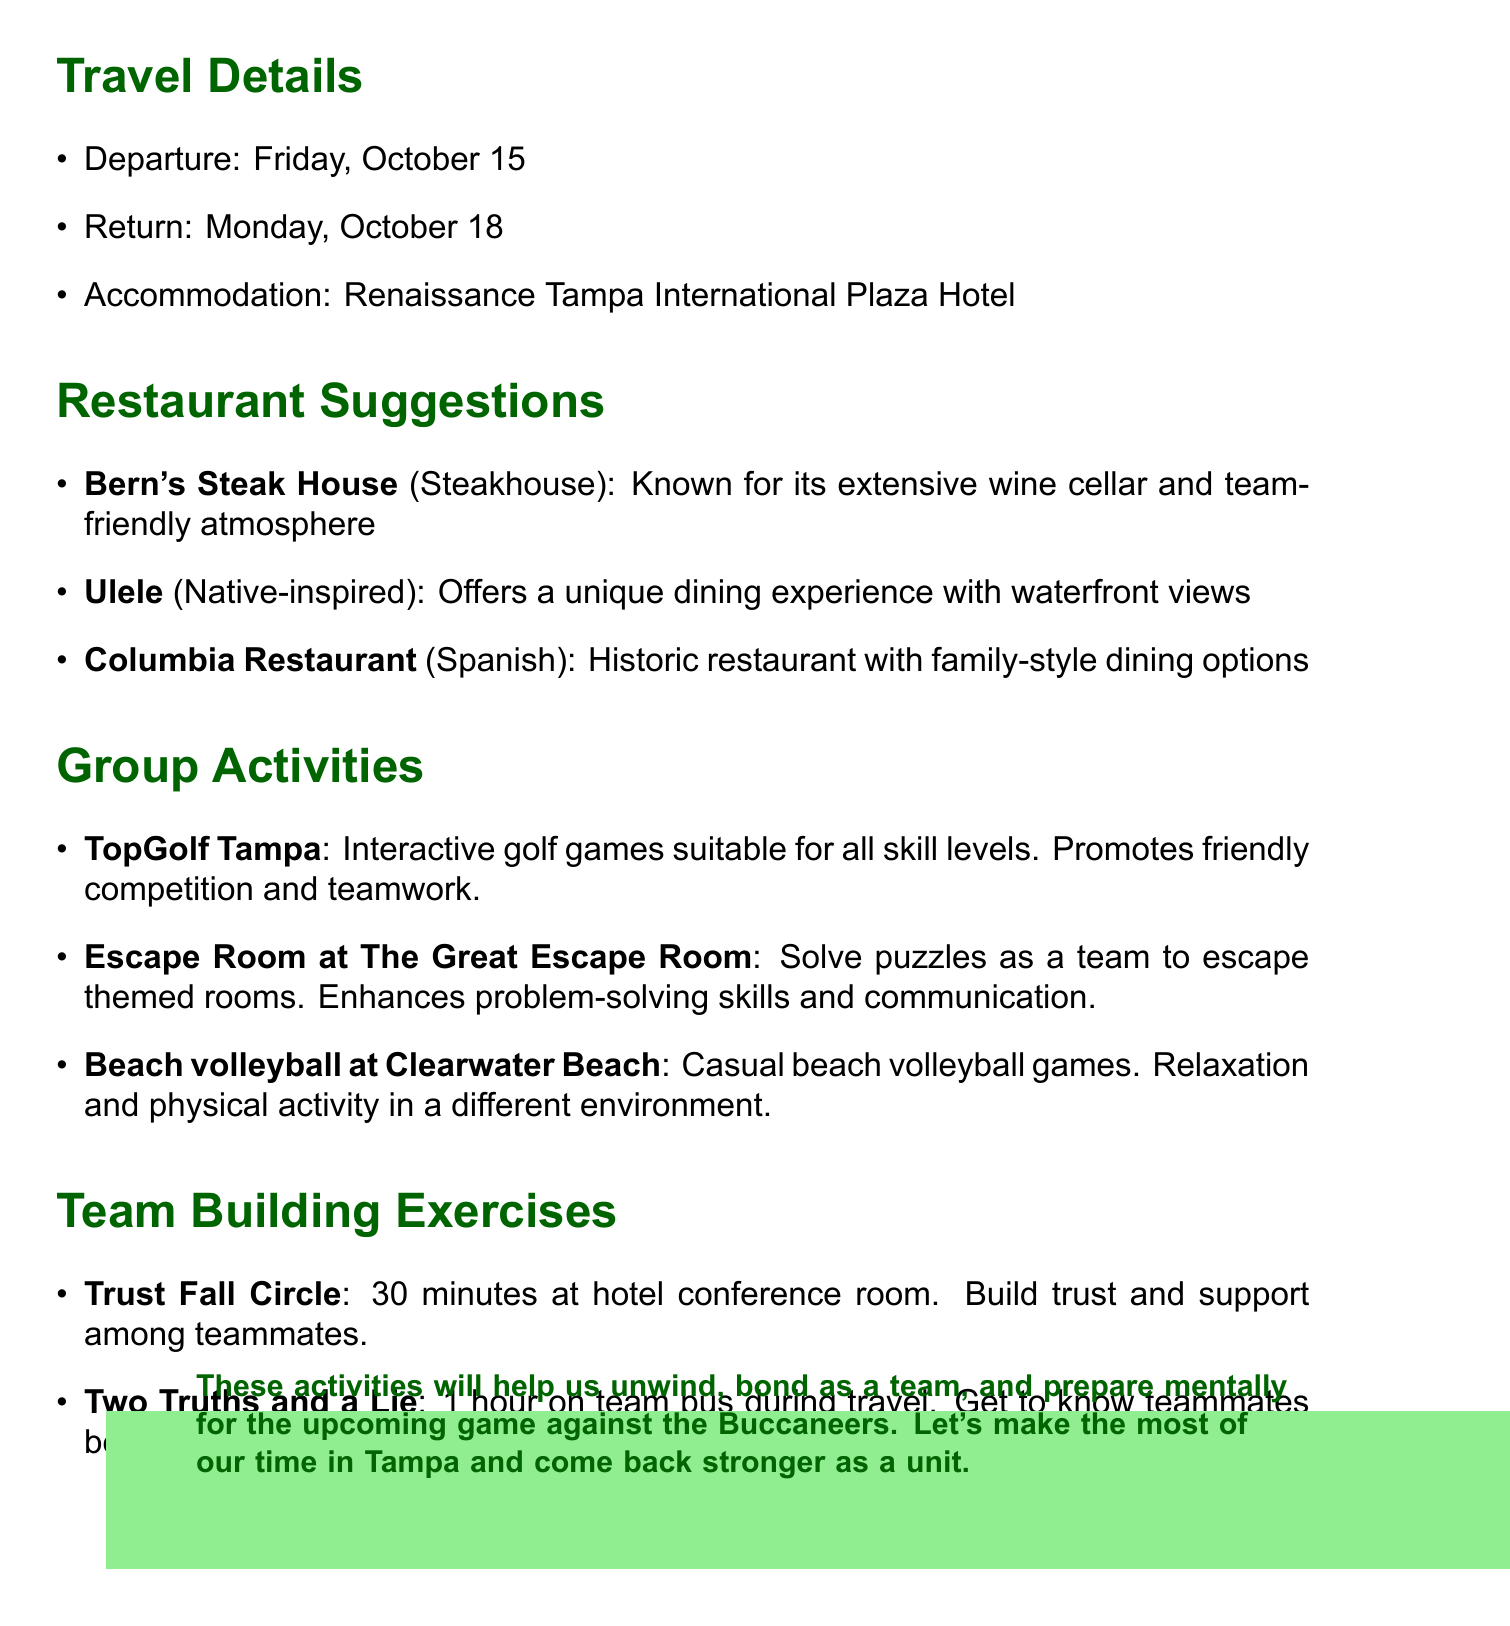What is the departure date for the trip? The departure date is clearly stated in the travel details section of the memo.
Answer: Friday, October 15 What is the name of the hotel for accommodation? The memo lists the hotel where the team will be staying during the trip.
Answer: Renaissance Tampa International Plaza Hotel Which restaurant offers a unique dining experience with waterfront views? One of the restaurant suggestions specifically highlights its unique dining experience with such views.
Answer: Ulele How long is the duration of the Trust Fall Circle exercise? The duration of the Trust Fall Circle is mentioned in the team building exercises section.
Answer: 30 minutes What group activity promotes friendly competition and teamwork? The memo describes a specific group activity that focuses on competition and teamwork benefits.
Answer: TopGolf Tampa What is the total return date? The return date is listed alongside the departure date in the travel details section.
Answer: Monday, October 18 Which team building exercise is conducted on the team bus? The memo specifies which exercise takes place on the team bus during travel.
Answer: Two Truths and a Lie What cuisine does Bern's Steak House serve? The type of cuisine served at Bern's Steak House is mentioned in the restaurant suggestions.
Answer: Steakhouse What beach activity is suggested for relaxation and physical activity? The memo includes a casual beach activity that combines relaxation and physical exercise.
Answer: Beach volleyball at Clearwater Beach 